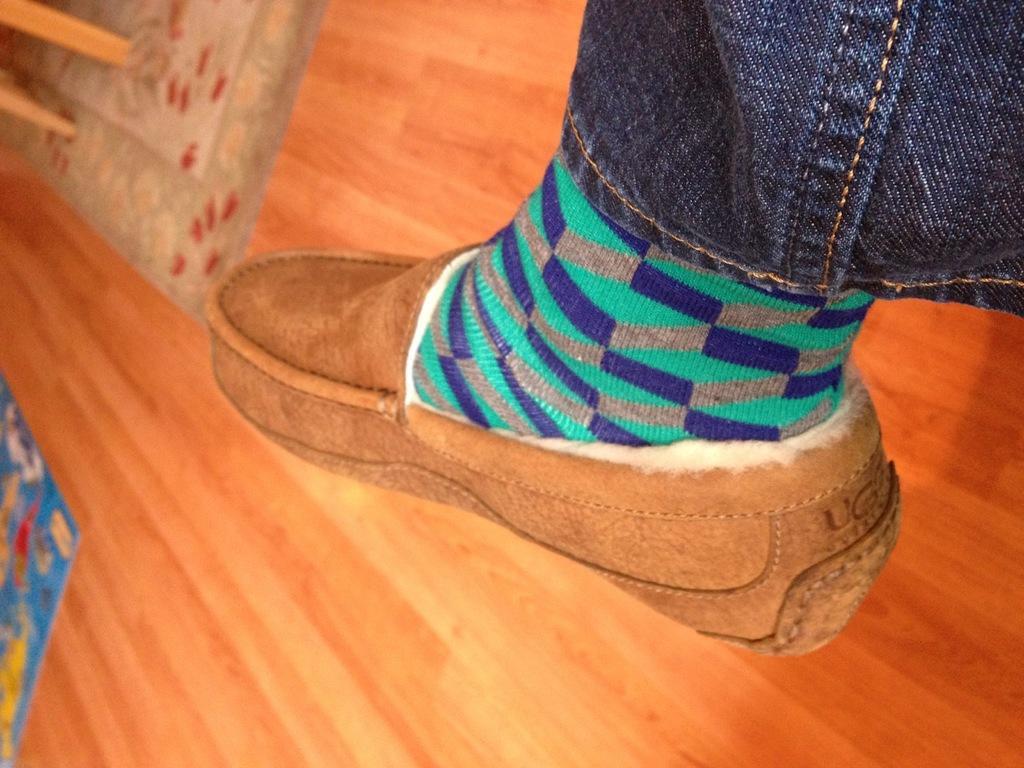Describe this image in one or two sentences. In this image I can see a colourful sock, a brown colour shoe and a jeans on the right side. On the left side of the image I can see two brown colour things and two colourful carpets on the floor. 